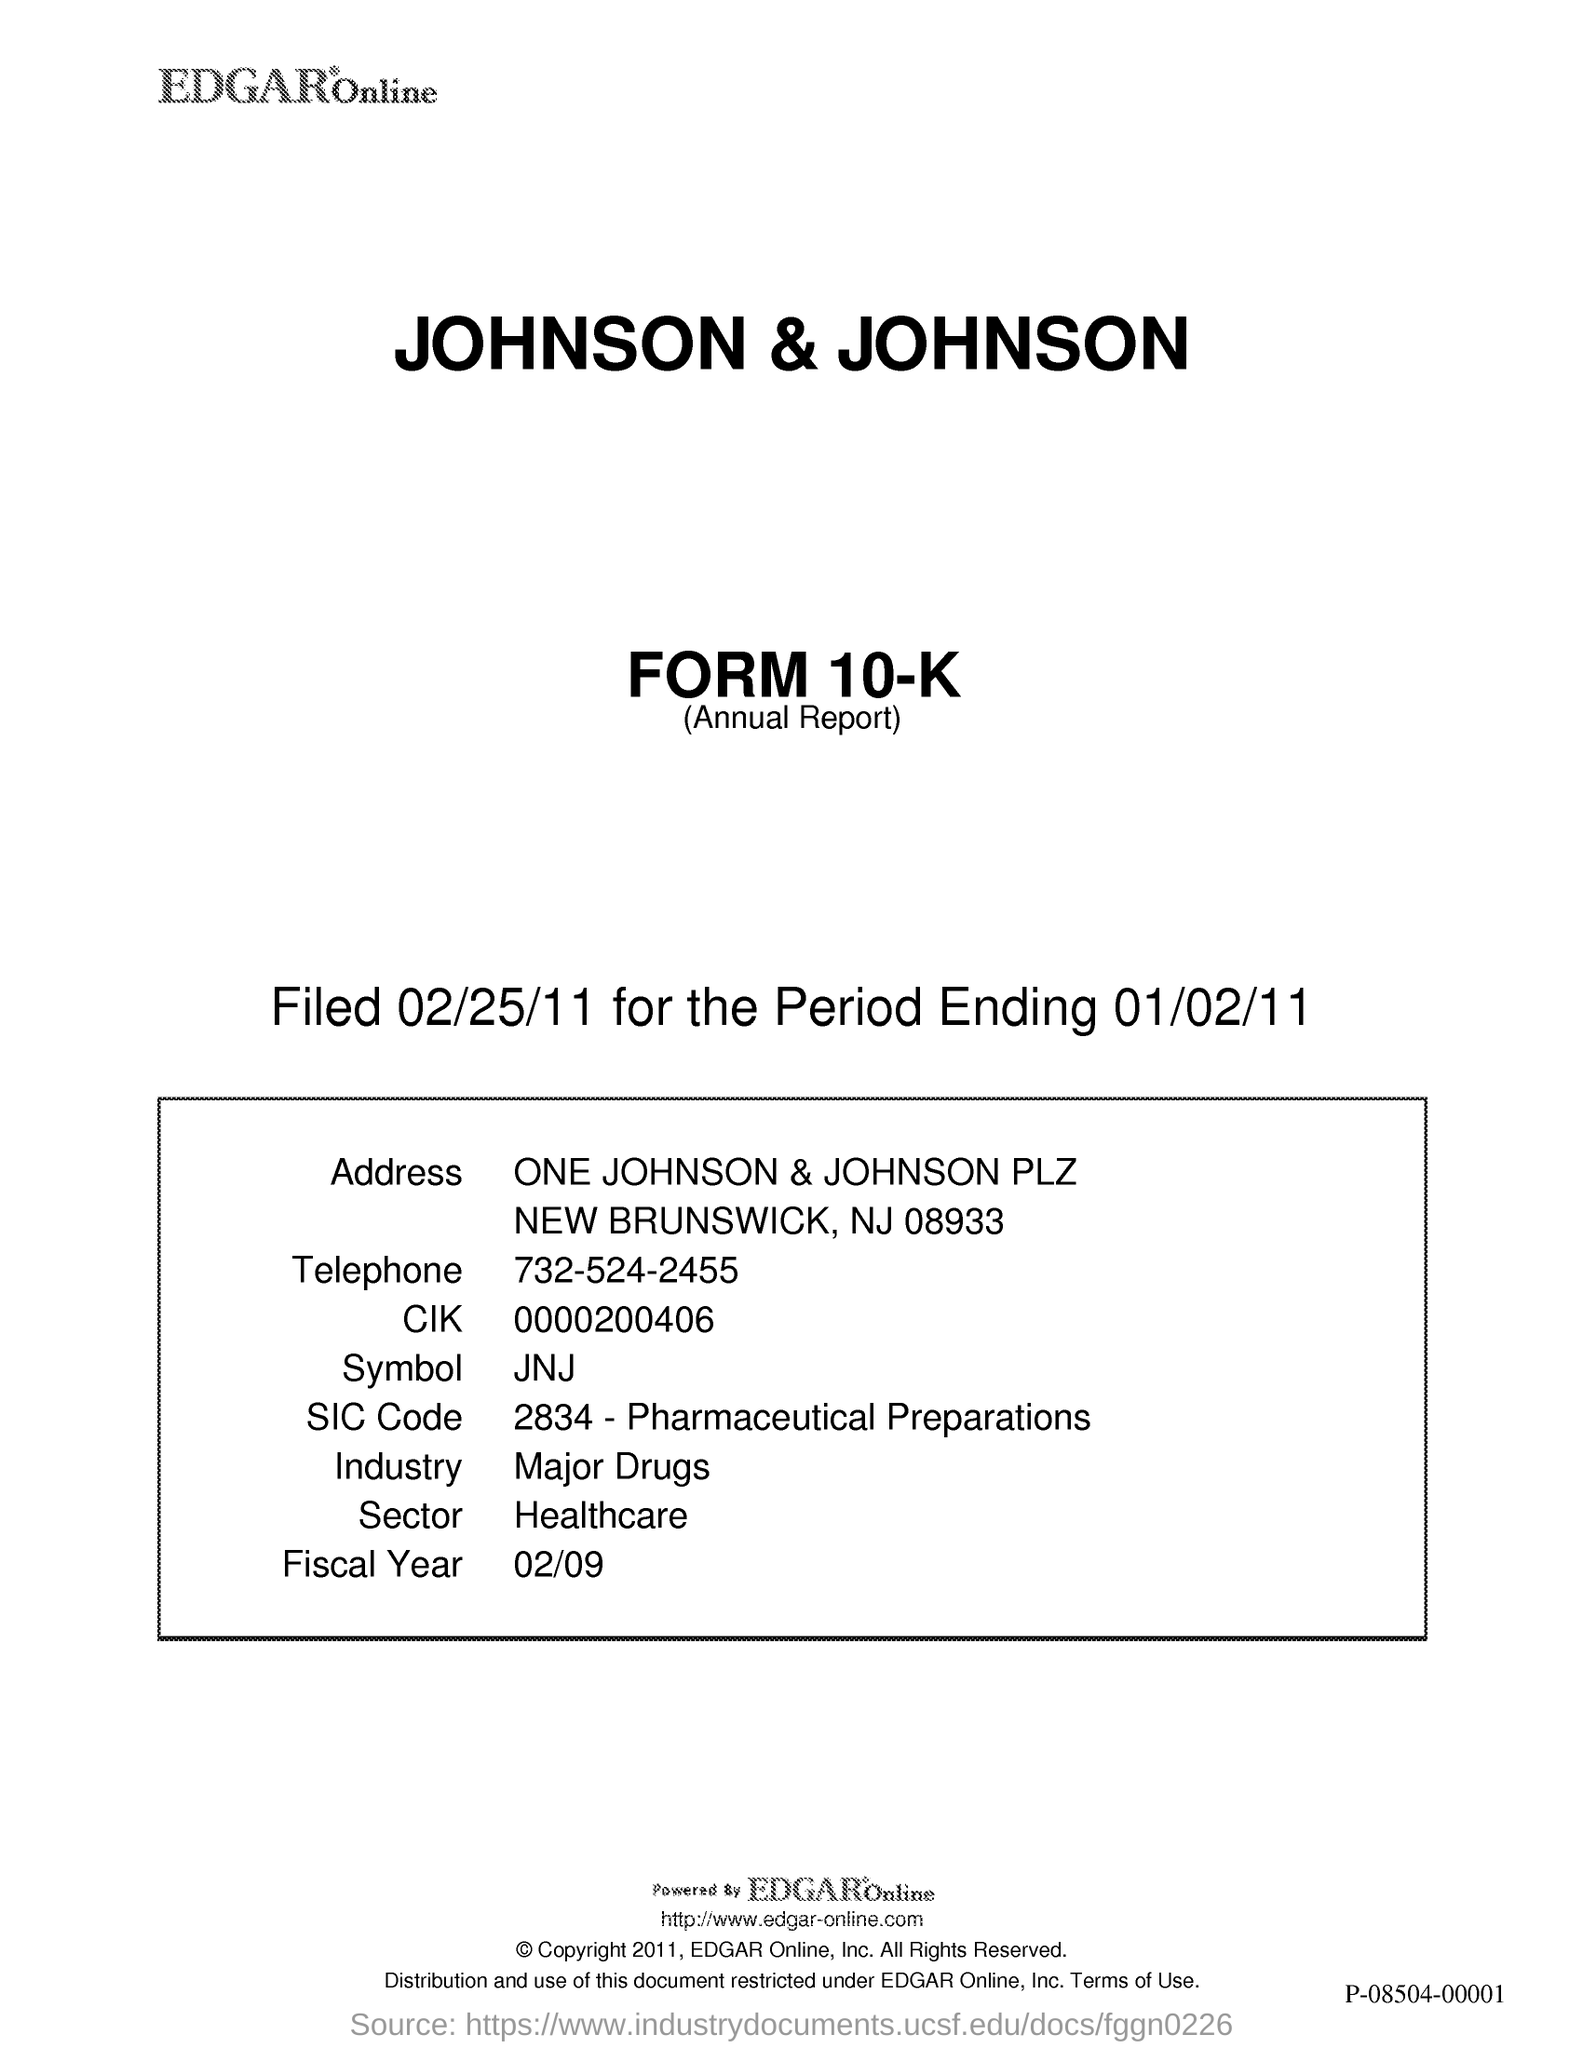Identify some key points in this picture. The SIC Code listed in the document is 2834, which pertains to Pharmaceutical Preparations. Johnson & Johnson belongs to the healthcare sector. The symbol mentioned in the document is JNJ. Johnson & Johnson is a pharmaceutical company that belongs to the major drug industry. The telephone number provided in this document is 732-524-2455. 